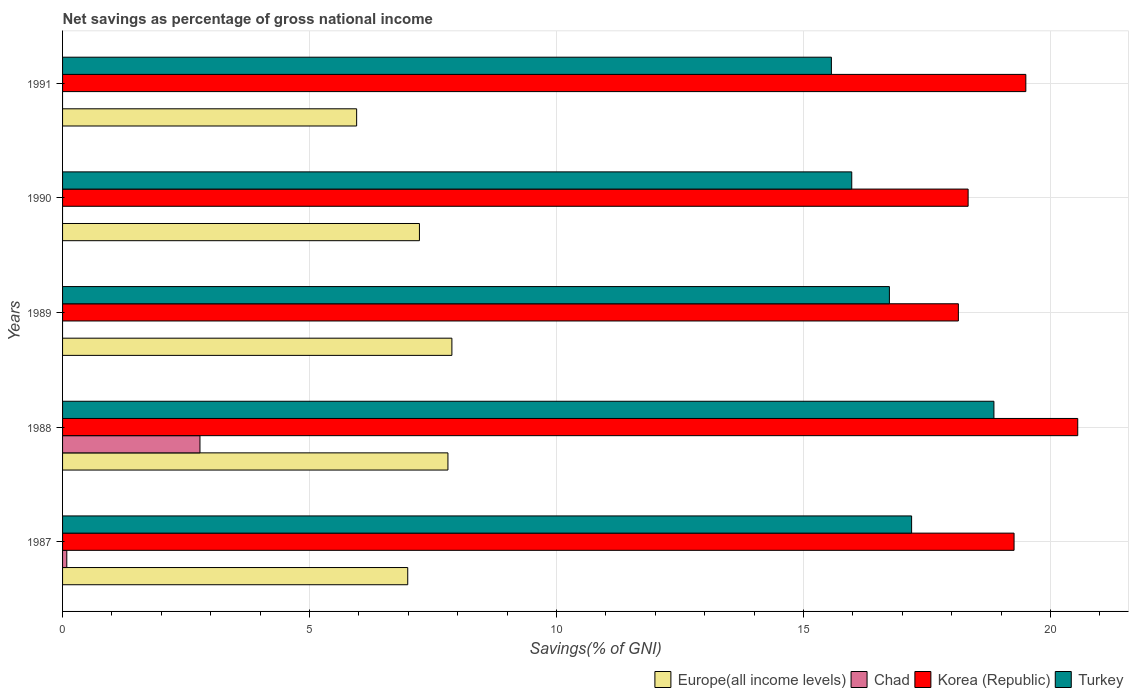How many different coloured bars are there?
Offer a very short reply. 4. Are the number of bars per tick equal to the number of legend labels?
Give a very brief answer. No. How many bars are there on the 2nd tick from the top?
Your answer should be very brief. 3. How many bars are there on the 3rd tick from the bottom?
Your response must be concise. 3. What is the total savings in Turkey in 1989?
Your response must be concise. 16.74. Across all years, what is the maximum total savings in Europe(all income levels)?
Your response must be concise. 7.88. What is the total total savings in Chad in the graph?
Offer a terse response. 2.87. What is the difference between the total savings in Korea (Republic) in 1988 and that in 1990?
Your response must be concise. 2.22. What is the difference between the total savings in Turkey in 1988 and the total savings in Chad in 1991?
Your answer should be compact. 18.86. What is the average total savings in Korea (Republic) per year?
Provide a succinct answer. 19.16. In the year 1991, what is the difference between the total savings in Europe(all income levels) and total savings in Turkey?
Give a very brief answer. -9.61. In how many years, is the total savings in Europe(all income levels) greater than 19 %?
Make the answer very short. 0. What is the ratio of the total savings in Europe(all income levels) in 1989 to that in 1991?
Your answer should be very brief. 1.32. Is the difference between the total savings in Europe(all income levels) in 1988 and 1991 greater than the difference between the total savings in Turkey in 1988 and 1991?
Offer a terse response. No. What is the difference between the highest and the second highest total savings in Turkey?
Keep it short and to the point. 1.67. What is the difference between the highest and the lowest total savings in Chad?
Provide a short and direct response. 2.78. In how many years, is the total savings in Turkey greater than the average total savings in Turkey taken over all years?
Give a very brief answer. 2. Is the sum of the total savings in Korea (Republic) in 1989 and 1991 greater than the maximum total savings in Chad across all years?
Your answer should be very brief. Yes. Is it the case that in every year, the sum of the total savings in Chad and total savings in Korea (Republic) is greater than the sum of total savings in Europe(all income levels) and total savings in Turkey?
Offer a very short reply. No. Is it the case that in every year, the sum of the total savings in Chad and total savings in Turkey is greater than the total savings in Europe(all income levels)?
Your answer should be compact. Yes. How many years are there in the graph?
Your answer should be compact. 5. What is the difference between two consecutive major ticks on the X-axis?
Offer a terse response. 5. Are the values on the major ticks of X-axis written in scientific E-notation?
Your answer should be very brief. No. Does the graph contain grids?
Your answer should be very brief. Yes. Where does the legend appear in the graph?
Provide a succinct answer. Bottom right. What is the title of the graph?
Give a very brief answer. Net savings as percentage of gross national income. Does "Palau" appear as one of the legend labels in the graph?
Your answer should be very brief. No. What is the label or title of the X-axis?
Make the answer very short. Savings(% of GNI). What is the Savings(% of GNI) in Europe(all income levels) in 1987?
Give a very brief answer. 6.99. What is the Savings(% of GNI) in Chad in 1987?
Provide a short and direct response. 0.09. What is the Savings(% of GNI) of Korea (Republic) in 1987?
Your response must be concise. 19.26. What is the Savings(% of GNI) of Turkey in 1987?
Your answer should be very brief. 17.19. What is the Savings(% of GNI) in Europe(all income levels) in 1988?
Your answer should be very brief. 7.8. What is the Savings(% of GNI) of Chad in 1988?
Offer a terse response. 2.78. What is the Savings(% of GNI) of Korea (Republic) in 1988?
Provide a succinct answer. 20.55. What is the Savings(% of GNI) in Turkey in 1988?
Your response must be concise. 18.86. What is the Savings(% of GNI) in Europe(all income levels) in 1989?
Your response must be concise. 7.88. What is the Savings(% of GNI) of Korea (Republic) in 1989?
Your answer should be very brief. 18.14. What is the Savings(% of GNI) of Turkey in 1989?
Your response must be concise. 16.74. What is the Savings(% of GNI) of Europe(all income levels) in 1990?
Provide a succinct answer. 7.23. What is the Savings(% of GNI) of Chad in 1990?
Your answer should be very brief. 0. What is the Savings(% of GNI) of Korea (Republic) in 1990?
Give a very brief answer. 18.33. What is the Savings(% of GNI) in Turkey in 1990?
Your answer should be very brief. 15.98. What is the Savings(% of GNI) in Europe(all income levels) in 1991?
Keep it short and to the point. 5.95. What is the Savings(% of GNI) in Chad in 1991?
Provide a short and direct response. 0. What is the Savings(% of GNI) of Korea (Republic) in 1991?
Make the answer very short. 19.5. What is the Savings(% of GNI) in Turkey in 1991?
Your answer should be very brief. 15.57. Across all years, what is the maximum Savings(% of GNI) in Europe(all income levels)?
Offer a very short reply. 7.88. Across all years, what is the maximum Savings(% of GNI) in Chad?
Make the answer very short. 2.78. Across all years, what is the maximum Savings(% of GNI) in Korea (Republic)?
Your answer should be compact. 20.55. Across all years, what is the maximum Savings(% of GNI) in Turkey?
Your answer should be compact. 18.86. Across all years, what is the minimum Savings(% of GNI) in Europe(all income levels)?
Ensure brevity in your answer.  5.95. Across all years, what is the minimum Savings(% of GNI) of Chad?
Offer a terse response. 0. Across all years, what is the minimum Savings(% of GNI) of Korea (Republic)?
Your response must be concise. 18.14. Across all years, what is the minimum Savings(% of GNI) in Turkey?
Offer a terse response. 15.57. What is the total Savings(% of GNI) of Europe(all income levels) in the graph?
Offer a terse response. 35.85. What is the total Savings(% of GNI) in Chad in the graph?
Provide a succinct answer. 2.87. What is the total Savings(% of GNI) of Korea (Republic) in the graph?
Your response must be concise. 95.79. What is the total Savings(% of GNI) of Turkey in the graph?
Provide a short and direct response. 84.33. What is the difference between the Savings(% of GNI) in Europe(all income levels) in 1987 and that in 1988?
Make the answer very short. -0.81. What is the difference between the Savings(% of GNI) in Chad in 1987 and that in 1988?
Provide a succinct answer. -2.7. What is the difference between the Savings(% of GNI) in Korea (Republic) in 1987 and that in 1988?
Ensure brevity in your answer.  -1.29. What is the difference between the Savings(% of GNI) of Turkey in 1987 and that in 1988?
Give a very brief answer. -1.67. What is the difference between the Savings(% of GNI) of Europe(all income levels) in 1987 and that in 1989?
Give a very brief answer. -0.89. What is the difference between the Savings(% of GNI) in Korea (Republic) in 1987 and that in 1989?
Make the answer very short. 1.13. What is the difference between the Savings(% of GNI) in Turkey in 1987 and that in 1989?
Offer a terse response. 0.45. What is the difference between the Savings(% of GNI) of Europe(all income levels) in 1987 and that in 1990?
Provide a succinct answer. -0.24. What is the difference between the Savings(% of GNI) of Korea (Republic) in 1987 and that in 1990?
Ensure brevity in your answer.  0.93. What is the difference between the Savings(% of GNI) of Turkey in 1987 and that in 1990?
Offer a terse response. 1.21. What is the difference between the Savings(% of GNI) of Europe(all income levels) in 1987 and that in 1991?
Provide a short and direct response. 1.03. What is the difference between the Savings(% of GNI) in Korea (Republic) in 1987 and that in 1991?
Your response must be concise. -0.24. What is the difference between the Savings(% of GNI) of Turkey in 1987 and that in 1991?
Provide a succinct answer. 1.62. What is the difference between the Savings(% of GNI) in Europe(all income levels) in 1988 and that in 1989?
Your response must be concise. -0.08. What is the difference between the Savings(% of GNI) in Korea (Republic) in 1988 and that in 1989?
Your response must be concise. 2.42. What is the difference between the Savings(% of GNI) of Turkey in 1988 and that in 1989?
Ensure brevity in your answer.  2.12. What is the difference between the Savings(% of GNI) of Europe(all income levels) in 1988 and that in 1990?
Your answer should be compact. 0.58. What is the difference between the Savings(% of GNI) in Korea (Republic) in 1988 and that in 1990?
Your answer should be very brief. 2.22. What is the difference between the Savings(% of GNI) in Turkey in 1988 and that in 1990?
Provide a succinct answer. 2.88. What is the difference between the Savings(% of GNI) of Europe(all income levels) in 1988 and that in 1991?
Ensure brevity in your answer.  1.85. What is the difference between the Savings(% of GNI) of Korea (Republic) in 1988 and that in 1991?
Your answer should be very brief. 1.05. What is the difference between the Savings(% of GNI) of Turkey in 1988 and that in 1991?
Your response must be concise. 3.29. What is the difference between the Savings(% of GNI) in Europe(all income levels) in 1989 and that in 1990?
Your response must be concise. 0.66. What is the difference between the Savings(% of GNI) in Korea (Republic) in 1989 and that in 1990?
Your response must be concise. -0.2. What is the difference between the Savings(% of GNI) of Turkey in 1989 and that in 1990?
Offer a very short reply. 0.76. What is the difference between the Savings(% of GNI) of Europe(all income levels) in 1989 and that in 1991?
Offer a very short reply. 1.93. What is the difference between the Savings(% of GNI) of Korea (Republic) in 1989 and that in 1991?
Give a very brief answer. -1.37. What is the difference between the Savings(% of GNI) in Turkey in 1989 and that in 1991?
Keep it short and to the point. 1.17. What is the difference between the Savings(% of GNI) of Europe(all income levels) in 1990 and that in 1991?
Provide a succinct answer. 1.27. What is the difference between the Savings(% of GNI) in Korea (Republic) in 1990 and that in 1991?
Offer a terse response. -1.17. What is the difference between the Savings(% of GNI) of Turkey in 1990 and that in 1991?
Offer a very short reply. 0.41. What is the difference between the Savings(% of GNI) of Europe(all income levels) in 1987 and the Savings(% of GNI) of Chad in 1988?
Your answer should be compact. 4.21. What is the difference between the Savings(% of GNI) in Europe(all income levels) in 1987 and the Savings(% of GNI) in Korea (Republic) in 1988?
Offer a very short reply. -13.57. What is the difference between the Savings(% of GNI) in Europe(all income levels) in 1987 and the Savings(% of GNI) in Turkey in 1988?
Your answer should be very brief. -11.87. What is the difference between the Savings(% of GNI) of Chad in 1987 and the Savings(% of GNI) of Korea (Republic) in 1988?
Offer a very short reply. -20.47. What is the difference between the Savings(% of GNI) of Chad in 1987 and the Savings(% of GNI) of Turkey in 1988?
Keep it short and to the point. -18.77. What is the difference between the Savings(% of GNI) in Korea (Republic) in 1987 and the Savings(% of GNI) in Turkey in 1988?
Provide a short and direct response. 0.41. What is the difference between the Savings(% of GNI) of Europe(all income levels) in 1987 and the Savings(% of GNI) of Korea (Republic) in 1989?
Offer a terse response. -11.15. What is the difference between the Savings(% of GNI) of Europe(all income levels) in 1987 and the Savings(% of GNI) of Turkey in 1989?
Give a very brief answer. -9.75. What is the difference between the Savings(% of GNI) in Chad in 1987 and the Savings(% of GNI) in Korea (Republic) in 1989?
Your answer should be very brief. -18.05. What is the difference between the Savings(% of GNI) of Chad in 1987 and the Savings(% of GNI) of Turkey in 1989?
Your answer should be compact. -16.66. What is the difference between the Savings(% of GNI) of Korea (Republic) in 1987 and the Savings(% of GNI) of Turkey in 1989?
Ensure brevity in your answer.  2.52. What is the difference between the Savings(% of GNI) of Europe(all income levels) in 1987 and the Savings(% of GNI) of Korea (Republic) in 1990?
Make the answer very short. -11.35. What is the difference between the Savings(% of GNI) in Europe(all income levels) in 1987 and the Savings(% of GNI) in Turkey in 1990?
Your response must be concise. -8.99. What is the difference between the Savings(% of GNI) of Chad in 1987 and the Savings(% of GNI) of Korea (Republic) in 1990?
Ensure brevity in your answer.  -18.25. What is the difference between the Savings(% of GNI) in Chad in 1987 and the Savings(% of GNI) in Turkey in 1990?
Your answer should be compact. -15.89. What is the difference between the Savings(% of GNI) of Korea (Republic) in 1987 and the Savings(% of GNI) of Turkey in 1990?
Offer a very short reply. 3.29. What is the difference between the Savings(% of GNI) of Europe(all income levels) in 1987 and the Savings(% of GNI) of Korea (Republic) in 1991?
Your answer should be very brief. -12.51. What is the difference between the Savings(% of GNI) of Europe(all income levels) in 1987 and the Savings(% of GNI) of Turkey in 1991?
Offer a very short reply. -8.58. What is the difference between the Savings(% of GNI) in Chad in 1987 and the Savings(% of GNI) in Korea (Republic) in 1991?
Provide a succinct answer. -19.42. What is the difference between the Savings(% of GNI) of Chad in 1987 and the Savings(% of GNI) of Turkey in 1991?
Your response must be concise. -15.48. What is the difference between the Savings(% of GNI) of Korea (Republic) in 1987 and the Savings(% of GNI) of Turkey in 1991?
Your answer should be very brief. 3.7. What is the difference between the Savings(% of GNI) in Europe(all income levels) in 1988 and the Savings(% of GNI) in Korea (Republic) in 1989?
Your answer should be very brief. -10.33. What is the difference between the Savings(% of GNI) of Europe(all income levels) in 1988 and the Savings(% of GNI) of Turkey in 1989?
Ensure brevity in your answer.  -8.94. What is the difference between the Savings(% of GNI) of Chad in 1988 and the Savings(% of GNI) of Korea (Republic) in 1989?
Make the answer very short. -15.36. What is the difference between the Savings(% of GNI) of Chad in 1988 and the Savings(% of GNI) of Turkey in 1989?
Make the answer very short. -13.96. What is the difference between the Savings(% of GNI) of Korea (Republic) in 1988 and the Savings(% of GNI) of Turkey in 1989?
Your answer should be very brief. 3.81. What is the difference between the Savings(% of GNI) of Europe(all income levels) in 1988 and the Savings(% of GNI) of Korea (Republic) in 1990?
Provide a short and direct response. -10.53. What is the difference between the Savings(% of GNI) in Europe(all income levels) in 1988 and the Savings(% of GNI) in Turkey in 1990?
Your response must be concise. -8.18. What is the difference between the Savings(% of GNI) of Chad in 1988 and the Savings(% of GNI) of Korea (Republic) in 1990?
Your response must be concise. -15.55. What is the difference between the Savings(% of GNI) of Chad in 1988 and the Savings(% of GNI) of Turkey in 1990?
Keep it short and to the point. -13.2. What is the difference between the Savings(% of GNI) of Korea (Republic) in 1988 and the Savings(% of GNI) of Turkey in 1990?
Your response must be concise. 4.58. What is the difference between the Savings(% of GNI) in Europe(all income levels) in 1988 and the Savings(% of GNI) in Korea (Republic) in 1991?
Your answer should be very brief. -11.7. What is the difference between the Savings(% of GNI) of Europe(all income levels) in 1988 and the Savings(% of GNI) of Turkey in 1991?
Provide a short and direct response. -7.76. What is the difference between the Savings(% of GNI) in Chad in 1988 and the Savings(% of GNI) in Korea (Republic) in 1991?
Keep it short and to the point. -16.72. What is the difference between the Savings(% of GNI) of Chad in 1988 and the Savings(% of GNI) of Turkey in 1991?
Offer a terse response. -12.78. What is the difference between the Savings(% of GNI) of Korea (Republic) in 1988 and the Savings(% of GNI) of Turkey in 1991?
Your response must be concise. 4.99. What is the difference between the Savings(% of GNI) in Europe(all income levels) in 1989 and the Savings(% of GNI) in Korea (Republic) in 1990?
Offer a very short reply. -10.45. What is the difference between the Savings(% of GNI) of Europe(all income levels) in 1989 and the Savings(% of GNI) of Turkey in 1990?
Ensure brevity in your answer.  -8.1. What is the difference between the Savings(% of GNI) in Korea (Republic) in 1989 and the Savings(% of GNI) in Turkey in 1990?
Your response must be concise. 2.16. What is the difference between the Savings(% of GNI) of Europe(all income levels) in 1989 and the Savings(% of GNI) of Korea (Republic) in 1991?
Your response must be concise. -11.62. What is the difference between the Savings(% of GNI) of Europe(all income levels) in 1989 and the Savings(% of GNI) of Turkey in 1991?
Keep it short and to the point. -7.68. What is the difference between the Savings(% of GNI) of Korea (Republic) in 1989 and the Savings(% of GNI) of Turkey in 1991?
Offer a very short reply. 2.57. What is the difference between the Savings(% of GNI) of Europe(all income levels) in 1990 and the Savings(% of GNI) of Korea (Republic) in 1991?
Provide a succinct answer. -12.28. What is the difference between the Savings(% of GNI) in Europe(all income levels) in 1990 and the Savings(% of GNI) in Turkey in 1991?
Make the answer very short. -8.34. What is the difference between the Savings(% of GNI) of Korea (Republic) in 1990 and the Savings(% of GNI) of Turkey in 1991?
Ensure brevity in your answer.  2.77. What is the average Savings(% of GNI) of Europe(all income levels) per year?
Keep it short and to the point. 7.17. What is the average Savings(% of GNI) of Chad per year?
Your answer should be very brief. 0.57. What is the average Savings(% of GNI) of Korea (Republic) per year?
Ensure brevity in your answer.  19.16. What is the average Savings(% of GNI) of Turkey per year?
Provide a short and direct response. 16.87. In the year 1987, what is the difference between the Savings(% of GNI) of Europe(all income levels) and Savings(% of GNI) of Chad?
Make the answer very short. 6.9. In the year 1987, what is the difference between the Savings(% of GNI) in Europe(all income levels) and Savings(% of GNI) in Korea (Republic)?
Ensure brevity in your answer.  -12.28. In the year 1987, what is the difference between the Savings(% of GNI) in Europe(all income levels) and Savings(% of GNI) in Turkey?
Your answer should be compact. -10.2. In the year 1987, what is the difference between the Savings(% of GNI) in Chad and Savings(% of GNI) in Korea (Republic)?
Provide a succinct answer. -19.18. In the year 1987, what is the difference between the Savings(% of GNI) of Chad and Savings(% of GNI) of Turkey?
Provide a short and direct response. -17.1. In the year 1987, what is the difference between the Savings(% of GNI) of Korea (Republic) and Savings(% of GNI) of Turkey?
Your answer should be compact. 2.07. In the year 1988, what is the difference between the Savings(% of GNI) in Europe(all income levels) and Savings(% of GNI) in Chad?
Your answer should be very brief. 5.02. In the year 1988, what is the difference between the Savings(% of GNI) of Europe(all income levels) and Savings(% of GNI) of Korea (Republic)?
Provide a succinct answer. -12.75. In the year 1988, what is the difference between the Savings(% of GNI) of Europe(all income levels) and Savings(% of GNI) of Turkey?
Make the answer very short. -11.05. In the year 1988, what is the difference between the Savings(% of GNI) in Chad and Savings(% of GNI) in Korea (Republic)?
Offer a very short reply. -17.77. In the year 1988, what is the difference between the Savings(% of GNI) of Chad and Savings(% of GNI) of Turkey?
Make the answer very short. -16.07. In the year 1988, what is the difference between the Savings(% of GNI) of Korea (Republic) and Savings(% of GNI) of Turkey?
Offer a very short reply. 1.7. In the year 1989, what is the difference between the Savings(% of GNI) of Europe(all income levels) and Savings(% of GNI) of Korea (Republic)?
Give a very brief answer. -10.25. In the year 1989, what is the difference between the Savings(% of GNI) in Europe(all income levels) and Savings(% of GNI) in Turkey?
Offer a terse response. -8.86. In the year 1989, what is the difference between the Savings(% of GNI) of Korea (Republic) and Savings(% of GNI) of Turkey?
Give a very brief answer. 1.4. In the year 1990, what is the difference between the Savings(% of GNI) of Europe(all income levels) and Savings(% of GNI) of Korea (Republic)?
Offer a very short reply. -11.11. In the year 1990, what is the difference between the Savings(% of GNI) of Europe(all income levels) and Savings(% of GNI) of Turkey?
Offer a very short reply. -8.75. In the year 1990, what is the difference between the Savings(% of GNI) of Korea (Republic) and Savings(% of GNI) of Turkey?
Offer a terse response. 2.36. In the year 1991, what is the difference between the Savings(% of GNI) of Europe(all income levels) and Savings(% of GNI) of Korea (Republic)?
Offer a terse response. -13.55. In the year 1991, what is the difference between the Savings(% of GNI) of Europe(all income levels) and Savings(% of GNI) of Turkey?
Provide a succinct answer. -9.61. In the year 1991, what is the difference between the Savings(% of GNI) in Korea (Republic) and Savings(% of GNI) in Turkey?
Your answer should be very brief. 3.94. What is the ratio of the Savings(% of GNI) in Europe(all income levels) in 1987 to that in 1988?
Provide a succinct answer. 0.9. What is the ratio of the Savings(% of GNI) of Chad in 1987 to that in 1988?
Ensure brevity in your answer.  0.03. What is the ratio of the Savings(% of GNI) in Korea (Republic) in 1987 to that in 1988?
Your answer should be very brief. 0.94. What is the ratio of the Savings(% of GNI) of Turkey in 1987 to that in 1988?
Your answer should be very brief. 0.91. What is the ratio of the Savings(% of GNI) of Europe(all income levels) in 1987 to that in 1989?
Give a very brief answer. 0.89. What is the ratio of the Savings(% of GNI) in Korea (Republic) in 1987 to that in 1989?
Your response must be concise. 1.06. What is the ratio of the Savings(% of GNI) in Turkey in 1987 to that in 1989?
Your answer should be compact. 1.03. What is the ratio of the Savings(% of GNI) of Europe(all income levels) in 1987 to that in 1990?
Give a very brief answer. 0.97. What is the ratio of the Savings(% of GNI) in Korea (Republic) in 1987 to that in 1990?
Your response must be concise. 1.05. What is the ratio of the Savings(% of GNI) in Turkey in 1987 to that in 1990?
Ensure brevity in your answer.  1.08. What is the ratio of the Savings(% of GNI) of Europe(all income levels) in 1987 to that in 1991?
Offer a very short reply. 1.17. What is the ratio of the Savings(% of GNI) of Korea (Republic) in 1987 to that in 1991?
Offer a very short reply. 0.99. What is the ratio of the Savings(% of GNI) of Turkey in 1987 to that in 1991?
Your answer should be very brief. 1.1. What is the ratio of the Savings(% of GNI) of Europe(all income levels) in 1988 to that in 1989?
Ensure brevity in your answer.  0.99. What is the ratio of the Savings(% of GNI) in Korea (Republic) in 1988 to that in 1989?
Offer a terse response. 1.13. What is the ratio of the Savings(% of GNI) in Turkey in 1988 to that in 1989?
Ensure brevity in your answer.  1.13. What is the ratio of the Savings(% of GNI) of Europe(all income levels) in 1988 to that in 1990?
Your answer should be very brief. 1.08. What is the ratio of the Savings(% of GNI) of Korea (Republic) in 1988 to that in 1990?
Offer a very short reply. 1.12. What is the ratio of the Savings(% of GNI) of Turkey in 1988 to that in 1990?
Give a very brief answer. 1.18. What is the ratio of the Savings(% of GNI) of Europe(all income levels) in 1988 to that in 1991?
Offer a very short reply. 1.31. What is the ratio of the Savings(% of GNI) of Korea (Republic) in 1988 to that in 1991?
Your answer should be compact. 1.05. What is the ratio of the Savings(% of GNI) of Turkey in 1988 to that in 1991?
Your response must be concise. 1.21. What is the ratio of the Savings(% of GNI) in Europe(all income levels) in 1989 to that in 1990?
Your response must be concise. 1.09. What is the ratio of the Savings(% of GNI) in Turkey in 1989 to that in 1990?
Provide a short and direct response. 1.05. What is the ratio of the Savings(% of GNI) in Europe(all income levels) in 1989 to that in 1991?
Provide a succinct answer. 1.32. What is the ratio of the Savings(% of GNI) in Turkey in 1989 to that in 1991?
Provide a succinct answer. 1.08. What is the ratio of the Savings(% of GNI) in Europe(all income levels) in 1990 to that in 1991?
Give a very brief answer. 1.21. What is the ratio of the Savings(% of GNI) in Korea (Republic) in 1990 to that in 1991?
Provide a short and direct response. 0.94. What is the ratio of the Savings(% of GNI) in Turkey in 1990 to that in 1991?
Give a very brief answer. 1.03. What is the difference between the highest and the second highest Savings(% of GNI) in Korea (Republic)?
Provide a succinct answer. 1.05. What is the difference between the highest and the second highest Savings(% of GNI) of Turkey?
Provide a short and direct response. 1.67. What is the difference between the highest and the lowest Savings(% of GNI) of Europe(all income levels)?
Give a very brief answer. 1.93. What is the difference between the highest and the lowest Savings(% of GNI) in Chad?
Make the answer very short. 2.78. What is the difference between the highest and the lowest Savings(% of GNI) in Korea (Republic)?
Provide a short and direct response. 2.42. What is the difference between the highest and the lowest Savings(% of GNI) of Turkey?
Your response must be concise. 3.29. 